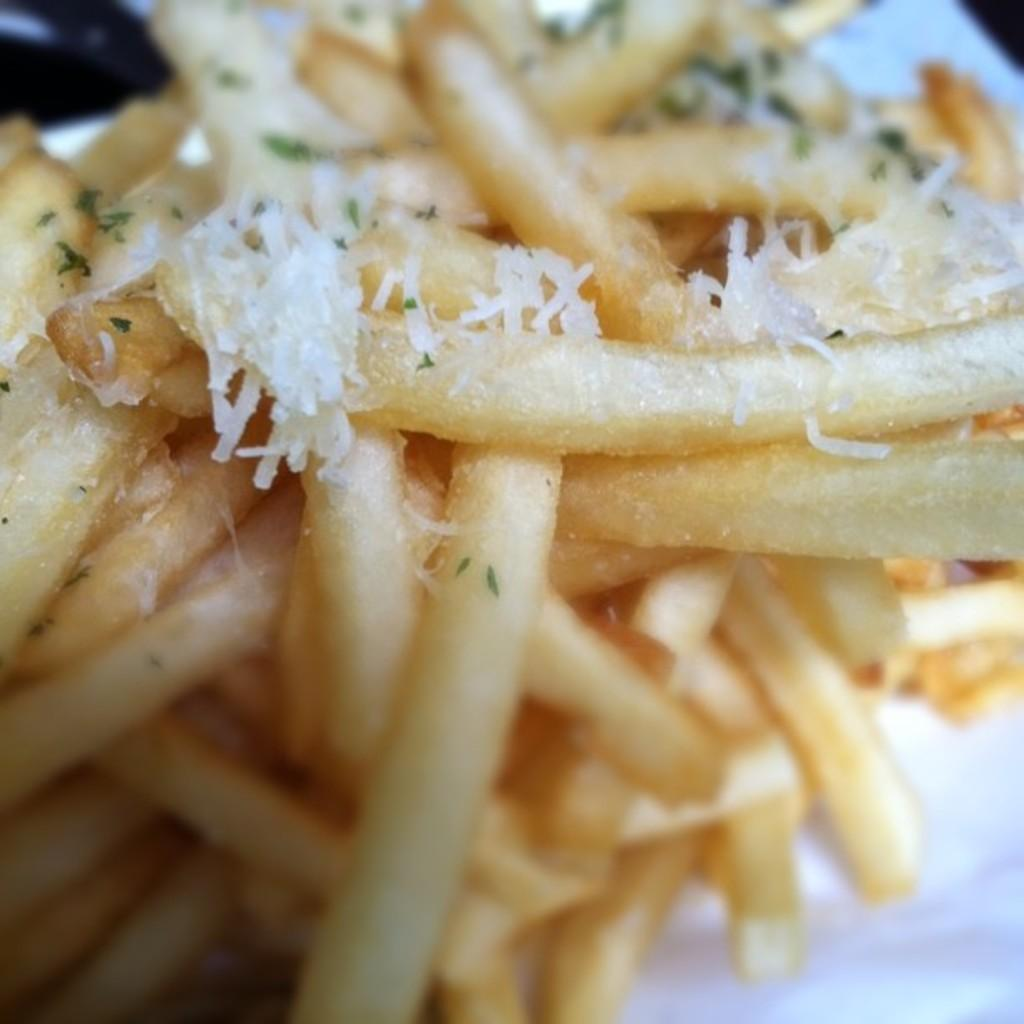What type of food is present in the image? There are French fries in the image. How are the French fries prepared or served? The French fries are garnished with cheese. How does the grandmother contribute to the activity in the image? There is no grandmother or activity present in the image; it only features French fries garnished with cheese. 